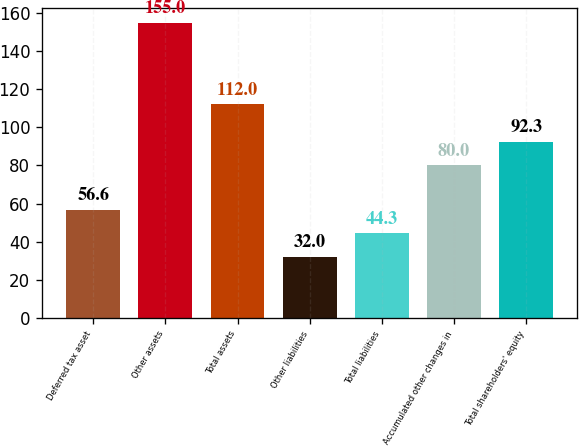<chart> <loc_0><loc_0><loc_500><loc_500><bar_chart><fcel>Deferred tax asset<fcel>Other assets<fcel>Total assets<fcel>Other liabilities<fcel>Total liabilities<fcel>Accumulated other changes in<fcel>Total shareholders' equity<nl><fcel>56.6<fcel>155<fcel>112<fcel>32<fcel>44.3<fcel>80<fcel>92.3<nl></chart> 